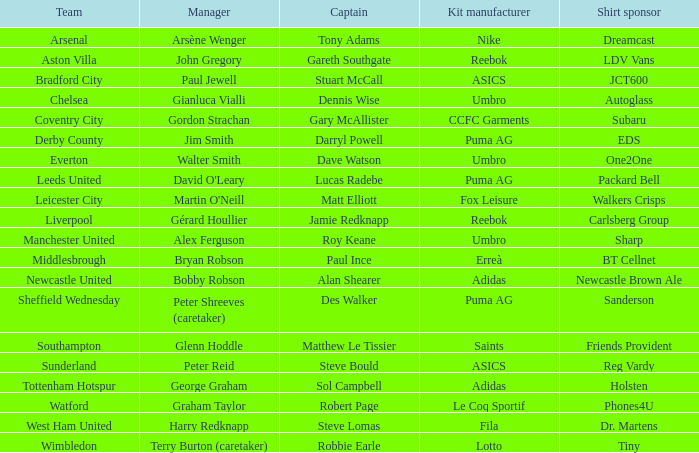Which Kit Manufacturer supports team Everton? Umbro. 